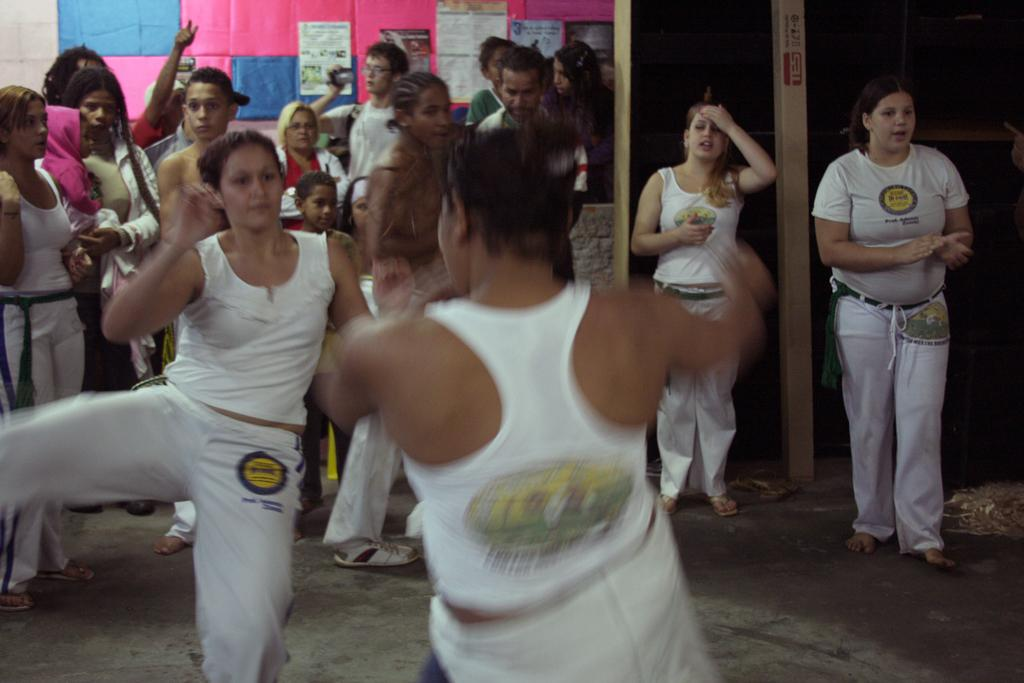How many people are in the image? There is a group of people in the image. What are two people in the group doing? Two people in the group are dancing. What can be seen in the background of the image? There are posters and a white color wall in the background of the image. What type of drug is the squirrel selling to the farmer in the image? There is no squirrel or farmer present in the image, and therefore no such transaction can be observed. 